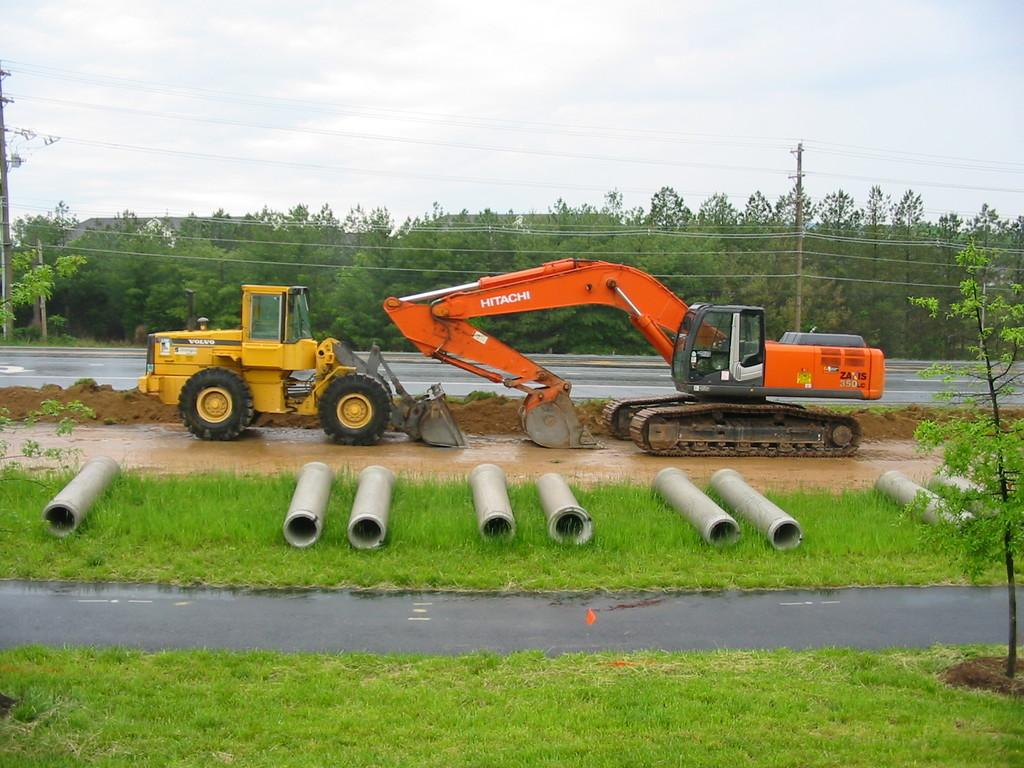What type of construction equipment can be seen in the image? There is a bulldozer and an excavator in the image. What type of terrain is visible at the bottom of the image? Grass is present at the bottom of the image. What other objects can be seen in the image besides the construction equipment? There are pipes visible in the image. What can be seen in the background of the image? There are poles, trees, and the sky visible in the background of the image. How many kittens are playing with the representative in the image? There are no kittens or representatives present in the image. What type of humor is being displayed by the construction equipment in the image? There is no humor displayed by the construction equipment in the image; it is simply performing its function. 